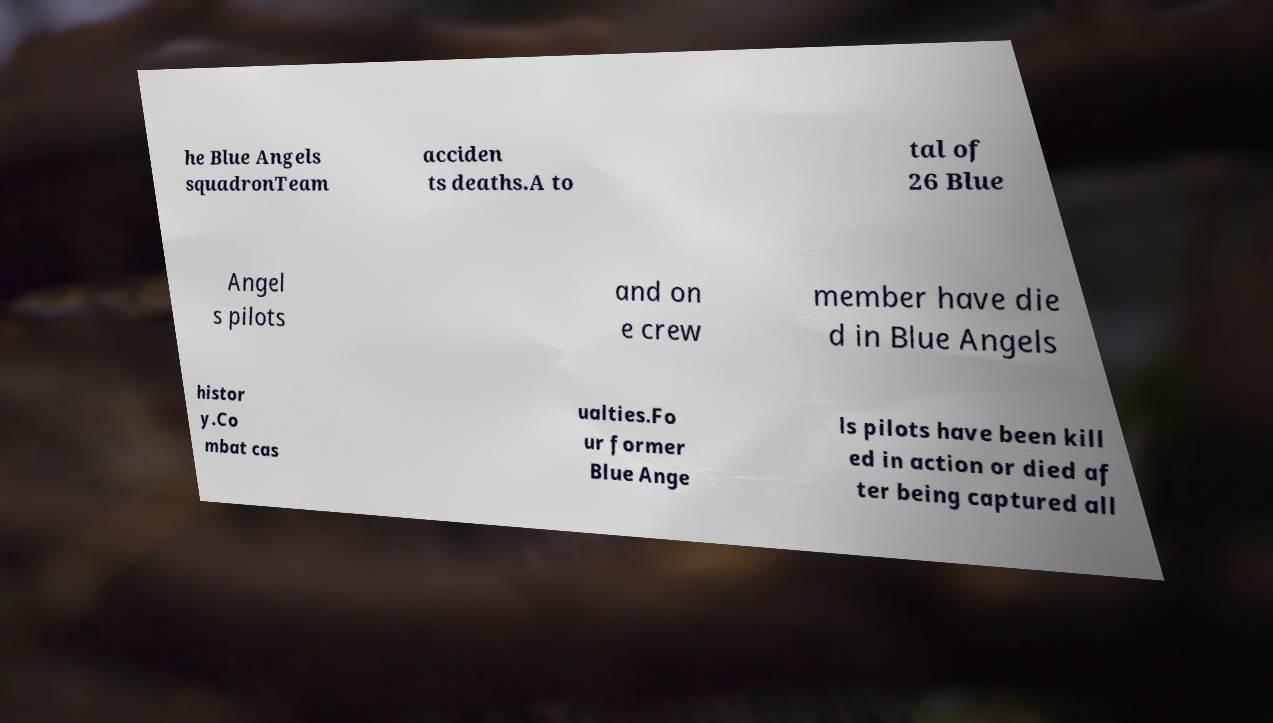Could you assist in decoding the text presented in this image and type it out clearly? he Blue Angels squadronTeam acciden ts deaths.A to tal of 26 Blue Angel s pilots and on e crew member have die d in Blue Angels histor y.Co mbat cas ualties.Fo ur former Blue Ange ls pilots have been kill ed in action or died af ter being captured all 